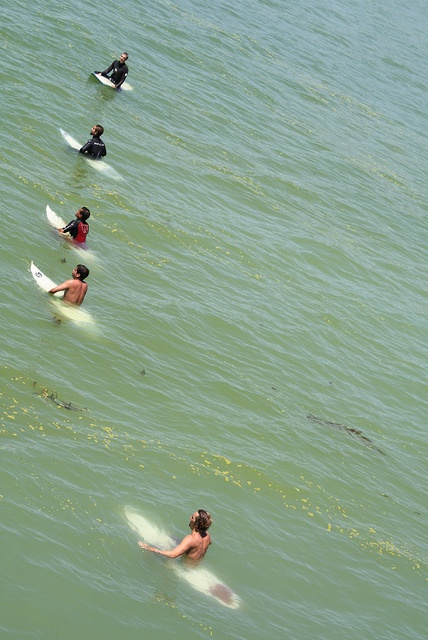Describe the objects in this image and their specific colors. I can see surfboard in teal, beige, and darkgray tones, people in teal, brown, tan, and black tones, surfboard in teal, beige, and darkgray tones, people in teal, brown, black, and salmon tones, and people in teal, black, maroon, brown, and gray tones in this image. 